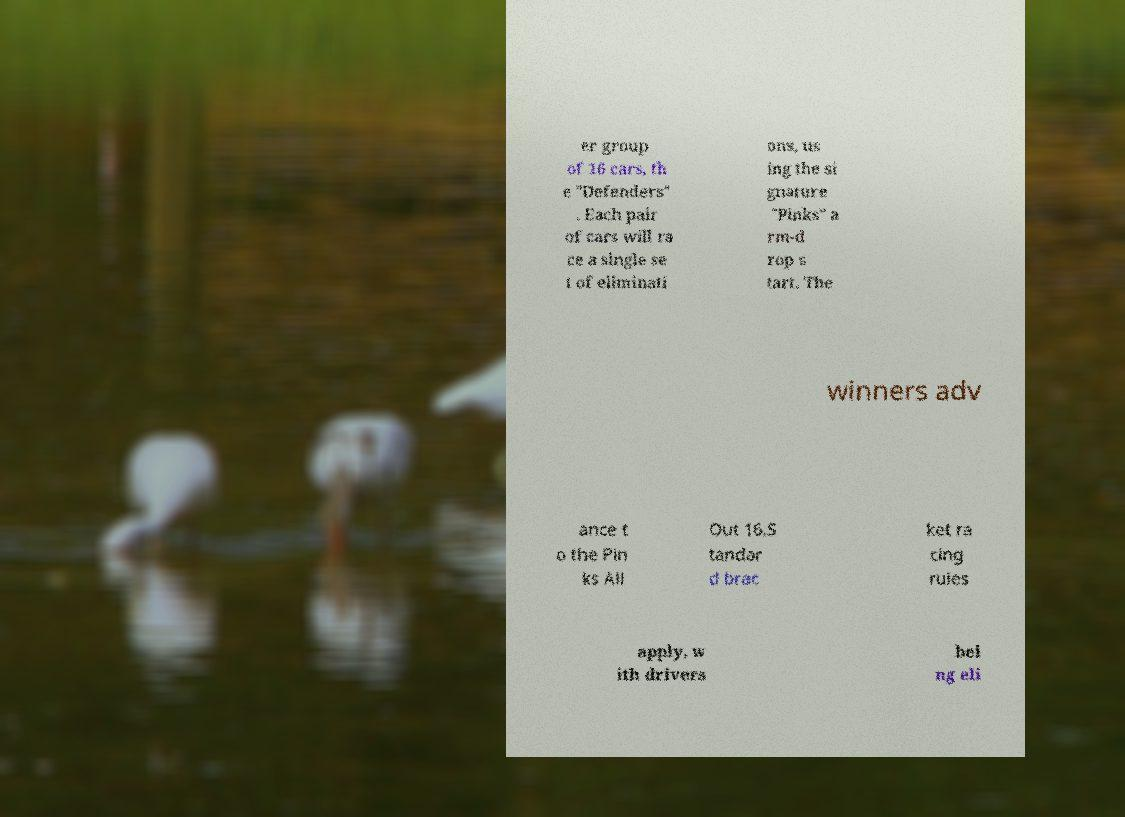Could you assist in decoding the text presented in this image and type it out clearly? er group of 16 cars, th e "Defenders" . Each pair of cars will ra ce a single se t of eliminati ons, us ing the si gnature "Pinks" a rm-d rop s tart. The winners adv ance t o the Pin ks All Out 16.S tandar d brac ket ra cing rules apply, w ith drivers bei ng eli 